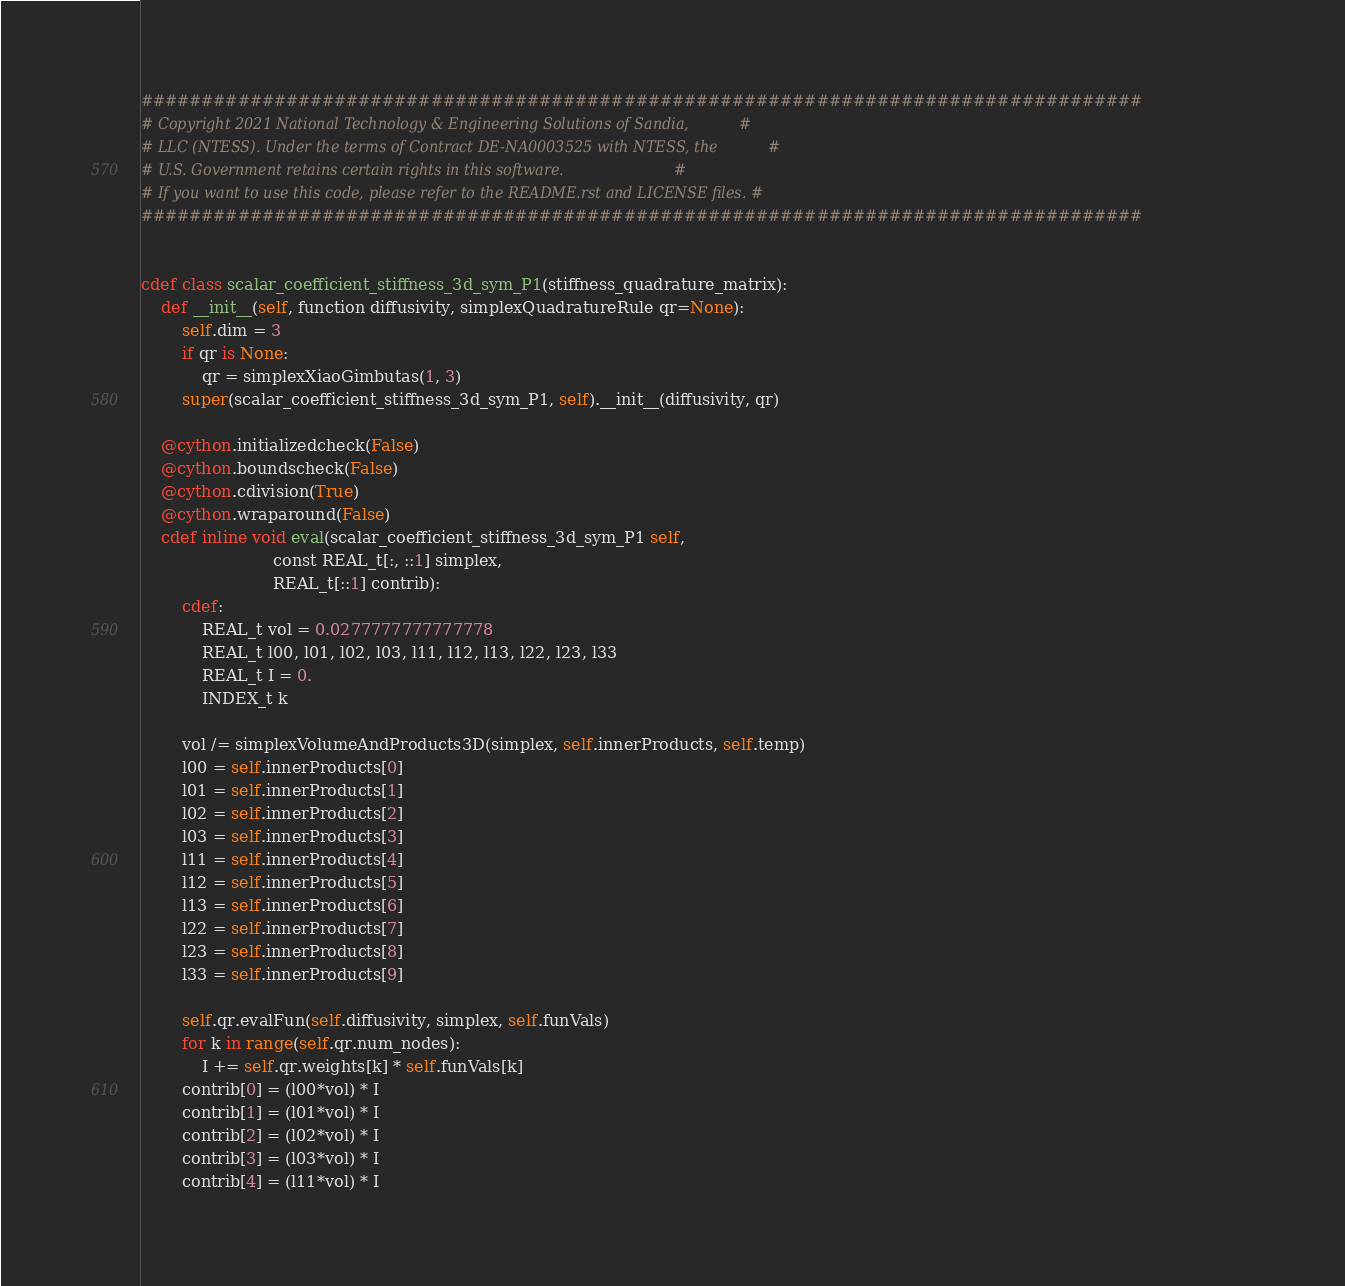<code> <loc_0><loc_0><loc_500><loc_500><_Cython_>###################################################################################
# Copyright 2021 National Technology & Engineering Solutions of Sandia,           #
# LLC (NTESS). Under the terms of Contract DE-NA0003525 with NTESS, the           #
# U.S. Government retains certain rights in this software.                        #
# If you want to use this code, please refer to the README.rst and LICENSE files. #
###################################################################################


cdef class scalar_coefficient_stiffness_3d_sym_P1(stiffness_quadrature_matrix):
    def __init__(self, function diffusivity, simplexQuadratureRule qr=None):
        self.dim = 3
        if qr is None:
            qr = simplexXiaoGimbutas(1, 3)
        super(scalar_coefficient_stiffness_3d_sym_P1, self).__init__(diffusivity, qr)

    @cython.initializedcheck(False)
    @cython.boundscheck(False)
    @cython.cdivision(True)
    @cython.wraparound(False)
    cdef inline void eval(scalar_coefficient_stiffness_3d_sym_P1 self,
                          const REAL_t[:, ::1] simplex,
                          REAL_t[::1] contrib):
        cdef:
            REAL_t vol = 0.0277777777777778
            REAL_t l00, l01, l02, l03, l11, l12, l13, l22, l23, l33
            REAL_t I = 0.
            INDEX_t k

        vol /= simplexVolumeAndProducts3D(simplex, self.innerProducts, self.temp)
        l00 = self.innerProducts[0]
        l01 = self.innerProducts[1]
        l02 = self.innerProducts[2]
        l03 = self.innerProducts[3]
        l11 = self.innerProducts[4]
        l12 = self.innerProducts[5]
        l13 = self.innerProducts[6]
        l22 = self.innerProducts[7]
        l23 = self.innerProducts[8]
        l33 = self.innerProducts[9]

        self.qr.evalFun(self.diffusivity, simplex, self.funVals)
        for k in range(self.qr.num_nodes):
            I += self.qr.weights[k] * self.funVals[k]
        contrib[0] = (l00*vol) * I
        contrib[1] = (l01*vol) * I
        contrib[2] = (l02*vol) * I
        contrib[3] = (l03*vol) * I
        contrib[4] = (l11*vol) * I</code> 